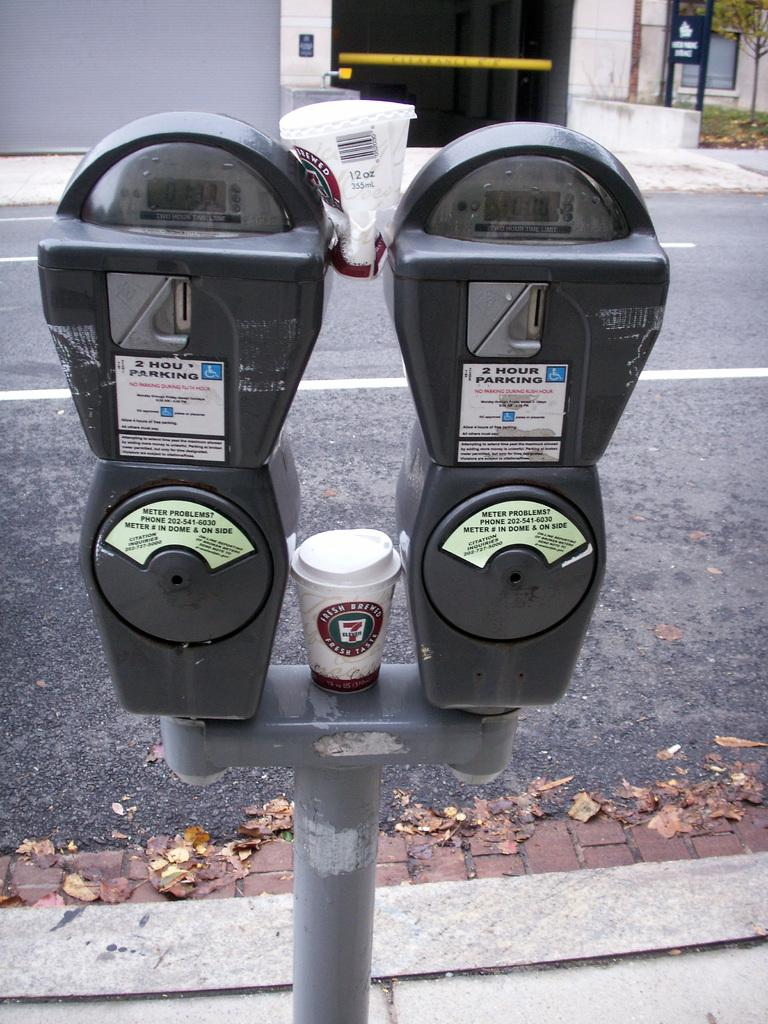What is the main subject in the center of the image? There are parking meters in the center of the image. What can be seen in the background of the image? There is a road and buildings visible in the background of the image. What type of vegetation is on the right side of the image? There is a tree on the right side of the image. How many fans are visible in the image? There are no fans present in the image. What is the desire of the parking meters in the image? Parking meters do not have desires, as they are inanimate objects. 